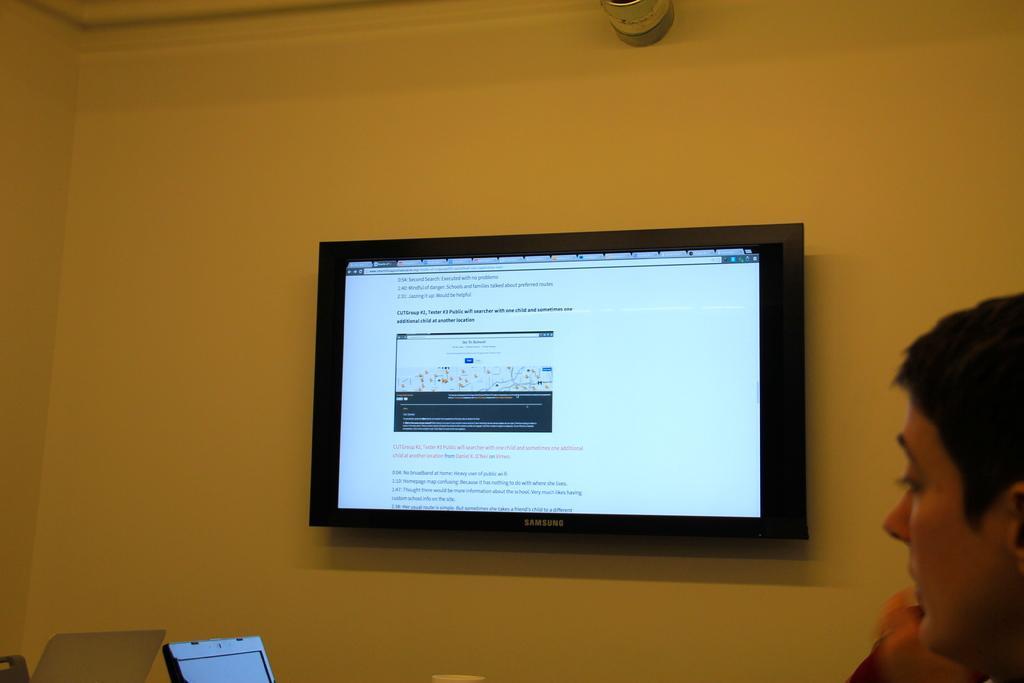Describe this image in one or two sentences. In the center of the image there is a tv on the wall. To the right side of the image there is a person. At the bottom of the image there is laptop. 